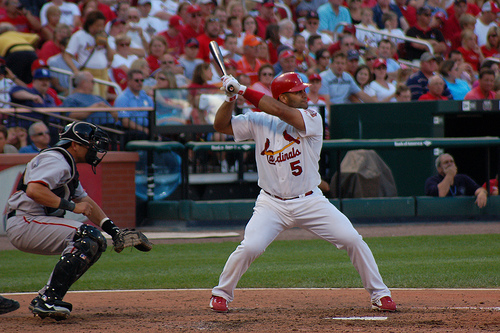Can you describe the scene around the player swinging the bat? Certainly. Aside from the batter poised to hit the ball, there is a catcher crouched behind him and an umpire standing close by, ready to make the call. The stands in the background are filled with spectators, suggesting this is a professional game with an engaged audience. 